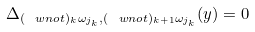Convert formula to latex. <formula><loc_0><loc_0><loc_500><loc_500>\Delta _ { ( \ w n o t ) _ { k } \omega _ { j _ { k } } , ( \ w n o t ) _ { k + 1 } \omega _ { j _ { k } } } ( y ) = 0</formula> 